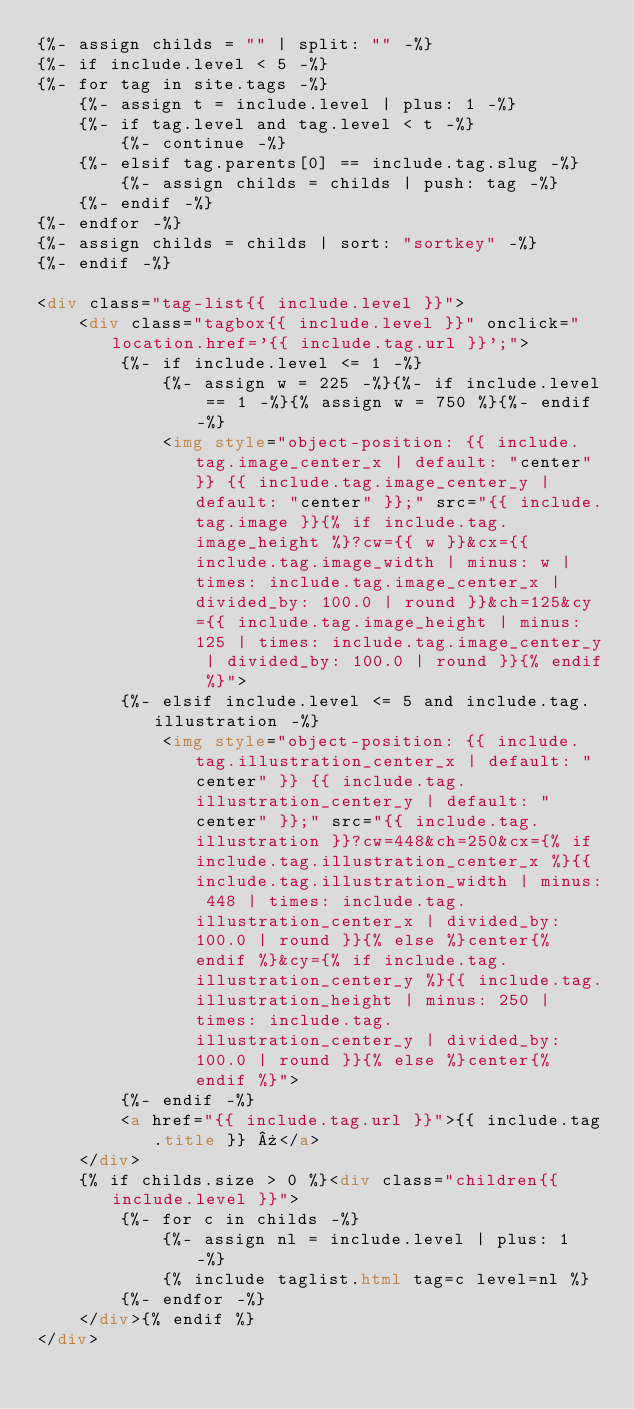<code> <loc_0><loc_0><loc_500><loc_500><_HTML_>{%- assign childs = "" | split: "" -%}
{%- if include.level < 5 -%}
{%- for tag in site.tags -%}
    {%- assign t = include.level | plus: 1 -%}
    {%- if tag.level and tag.level < t -%}
        {%- continue -%}
    {%- elsif tag.parents[0] == include.tag.slug -%}
        {%- assign childs = childs | push: tag -%}
    {%- endif -%}
{%- endfor -%}
{%- assign childs = childs | sort: "sortkey" -%}
{%- endif -%}

<div class="tag-list{{ include.level }}">
    <div class="tagbox{{ include.level }}" onclick="location.href='{{ include.tag.url }}';">
        {%- if include.level <= 1 -%}
            {%- assign w = 225 -%}{%- if include.level == 1 -%}{% assign w = 750 %}{%- endif -%}
            <img style="object-position: {{ include.tag.image_center_x | default: "center" }} {{ include.tag.image_center_y | default: "center" }};" src="{{ include.tag.image }}{% if include.tag.image_height %}?cw={{ w }}&cx={{ include.tag.image_width | minus: w | times: include.tag.image_center_x | divided_by: 100.0 | round }}&ch=125&cy={{ include.tag.image_height | minus: 125 | times: include.tag.image_center_y | divided_by: 100.0 | round }}{% endif %}">
        {%- elsif include.level <= 5 and include.tag.illustration -%}
            <img style="object-position: {{ include.tag.illustration_center_x | default: "center" }} {{ include.tag.illustration_center_y | default: "center" }};" src="{{ include.tag.illustration }}?cw=448&ch=250&cx={% if include.tag.illustration_center_x %}{{ include.tag.illustration_width | minus: 448 | times: include.tag.illustration_center_x | divided_by: 100.0 | round }}{% else %}center{% endif %}&cy={% if include.tag.illustration_center_y %}{{ include.tag.illustration_height | minus: 250 | times: include.tag.illustration_center_y | divided_by: 100.0 | round }}{% else %}center{% endif %}">
        {%- endif -%}
        <a href="{{ include.tag.url }}">{{ include.tag.title }} »</a>
    </div>
    {% if childs.size > 0 %}<div class="children{{ include.level }}">
        {%- for c in childs -%}
            {%- assign nl = include.level | plus: 1 -%}
            {% include taglist.html tag=c level=nl %}
        {%- endfor -%}
    </div>{% endif %}
</div>

</code> 